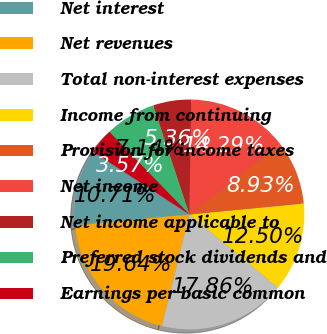<chart> <loc_0><loc_0><loc_500><loc_500><pie_chart><fcel>Net interest<fcel>Net revenues<fcel>Total non-interest expenses<fcel>Income from continuing<fcel>Provision for income taxes<fcel>Net income<fcel>Net income applicable to<fcel>Preferred stock dividends and<fcel>Earnings per basic common<nl><fcel>10.71%<fcel>19.64%<fcel>17.86%<fcel>12.5%<fcel>8.93%<fcel>14.29%<fcel>5.36%<fcel>7.14%<fcel>3.57%<nl></chart> 